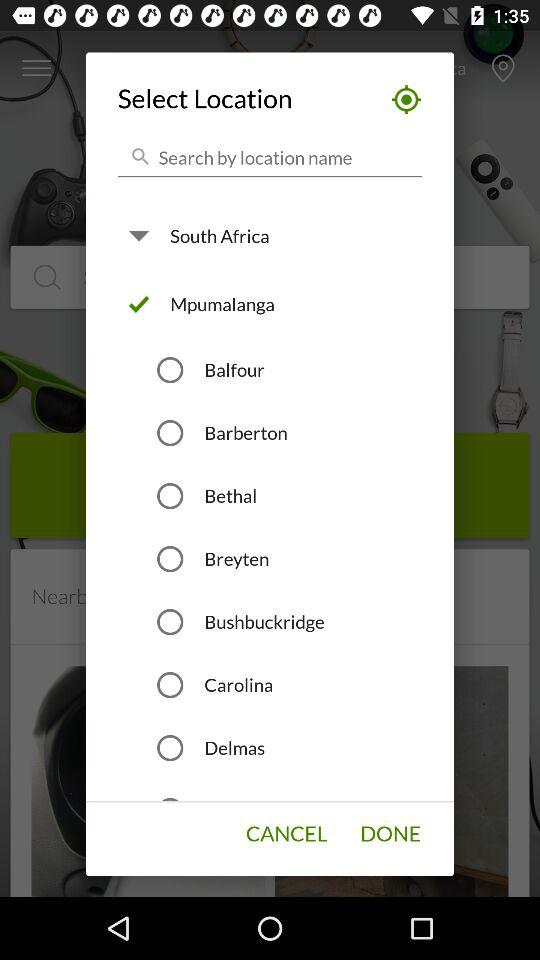Which location is selected? The selected location is Mpumalanga. 